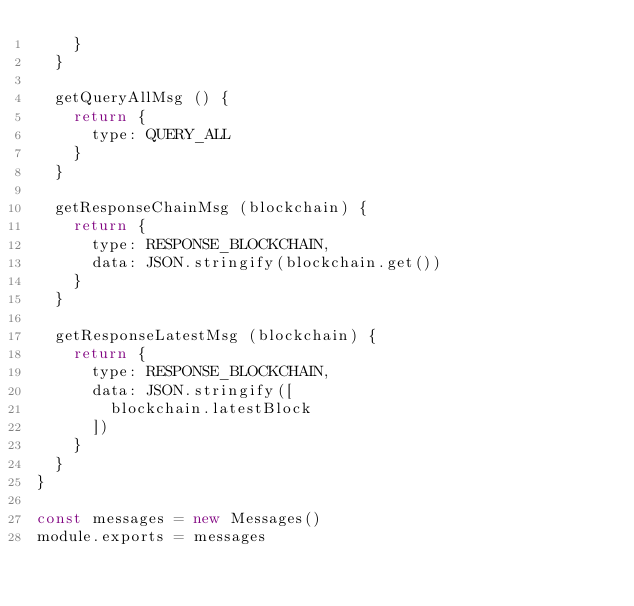<code> <loc_0><loc_0><loc_500><loc_500><_JavaScript_>    }
  }

  getQueryAllMsg () {
    return {
      type: QUERY_ALL
    }
  }

  getResponseChainMsg (blockchain) {
    return {
      type: RESPONSE_BLOCKCHAIN,
      data: JSON.stringify(blockchain.get())
    }
  }

  getResponseLatestMsg (blockchain) {
    return {
      type: RESPONSE_BLOCKCHAIN,
      data: JSON.stringify([
        blockchain.latestBlock
      ])
    }
  }
}

const messages = new Messages()
module.exports = messages
</code> 